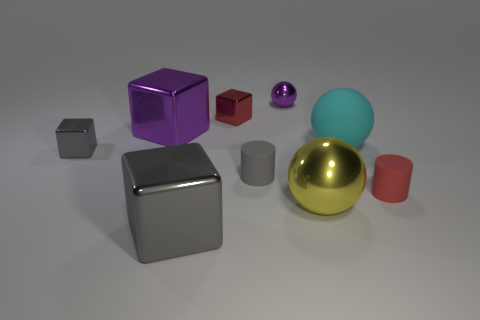Subtract 1 blocks. How many blocks are left? 3 Subtract all red cylinders. Subtract all gray balls. How many cylinders are left? 1 Add 1 small brown cylinders. How many objects exist? 10 Subtract all cylinders. How many objects are left? 7 Subtract 0 blue cylinders. How many objects are left? 9 Subtract all rubber balls. Subtract all large rubber objects. How many objects are left? 7 Add 6 tiny gray matte objects. How many tiny gray matte objects are left? 7 Add 4 large rubber things. How many large rubber things exist? 5 